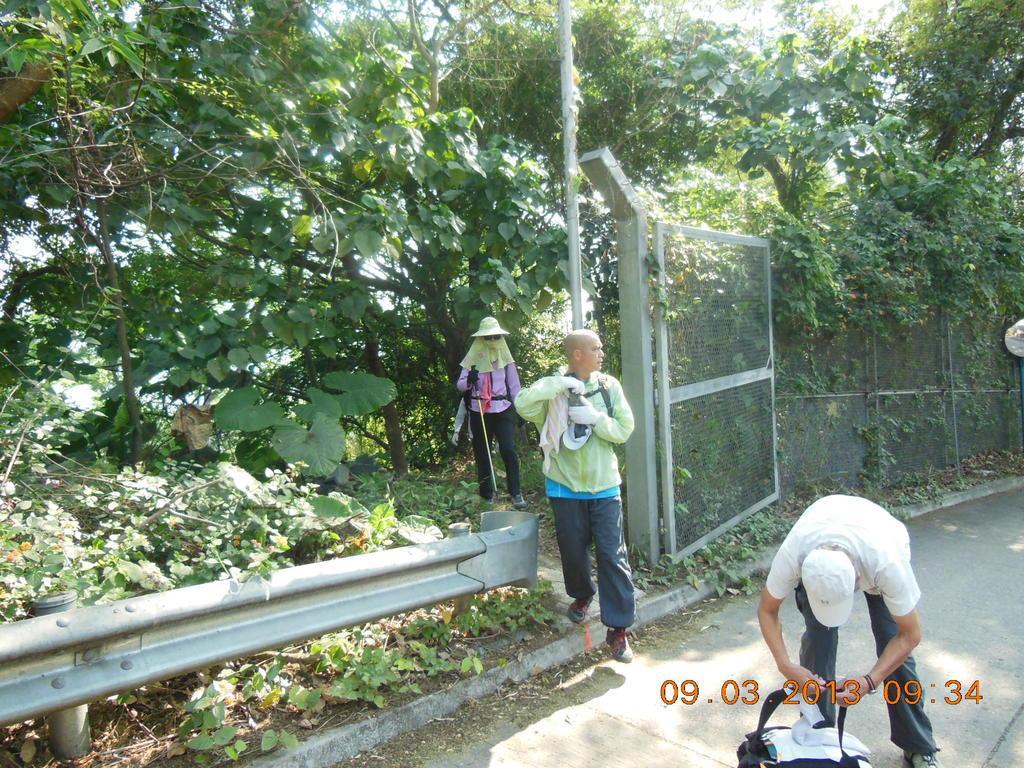Please provide a concise description of this image. In this image we can see persons standing on the road, creepers, trees, barriers, fencing and sky. 